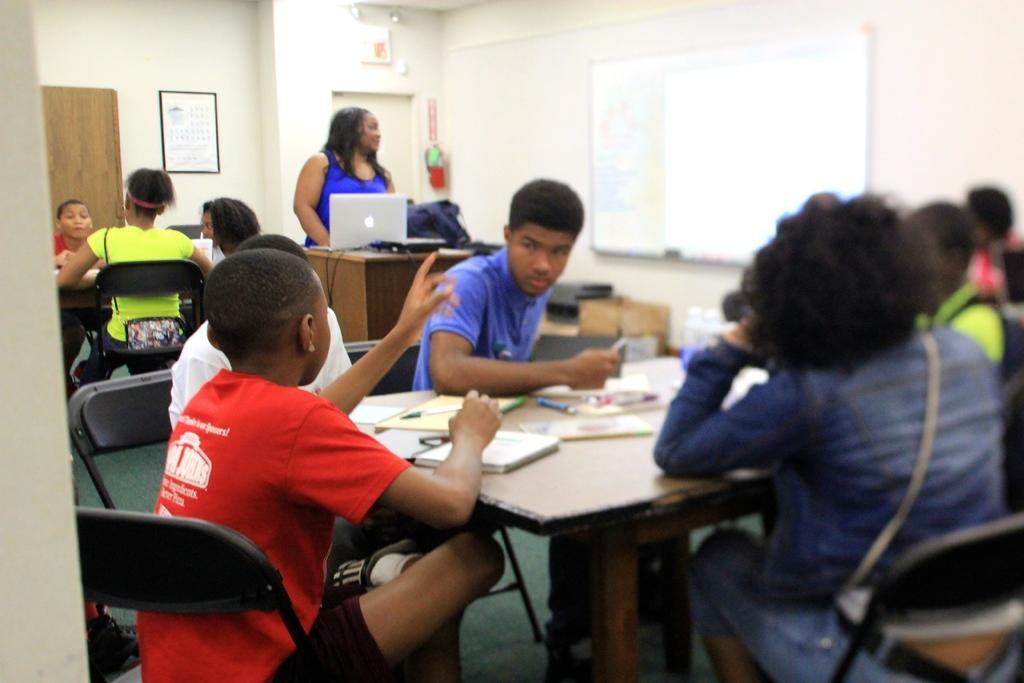Can you describe this image briefly? In front we can see few persons were sitting on the chair around the table. On table there is a pen,book and papers. In the center we can see one woman standing,in front of her there is a wood stand,tab and back pack. In the background there is a wall,cupboard,board and few persons were sitting on the chair. 